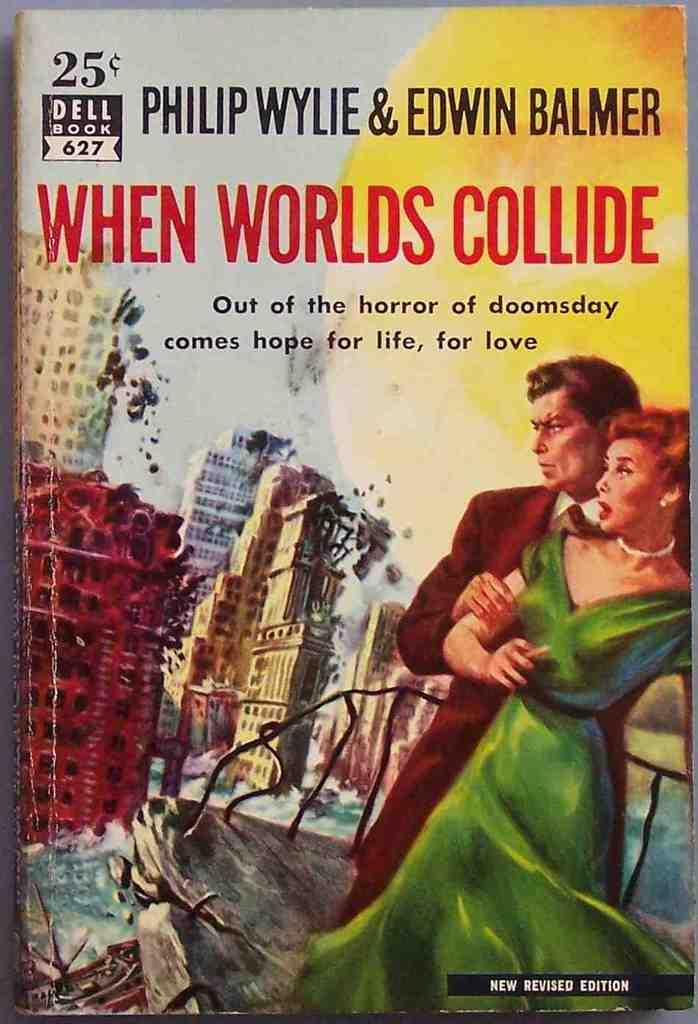<image>
Describe the image concisely. A book by Philip Wylie & Edwin Balmer entitled When Worlds Collide 